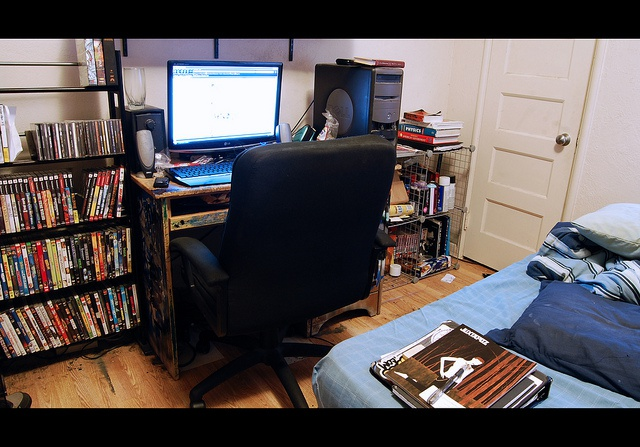Describe the objects in this image and their specific colors. I can see book in black, gray, darkgray, and maroon tones, chair in black, maroon, and gray tones, bed in black, lightblue, and gray tones, tv in black, white, navy, lightblue, and blue tones, and book in black, maroon, brown, and white tones in this image. 